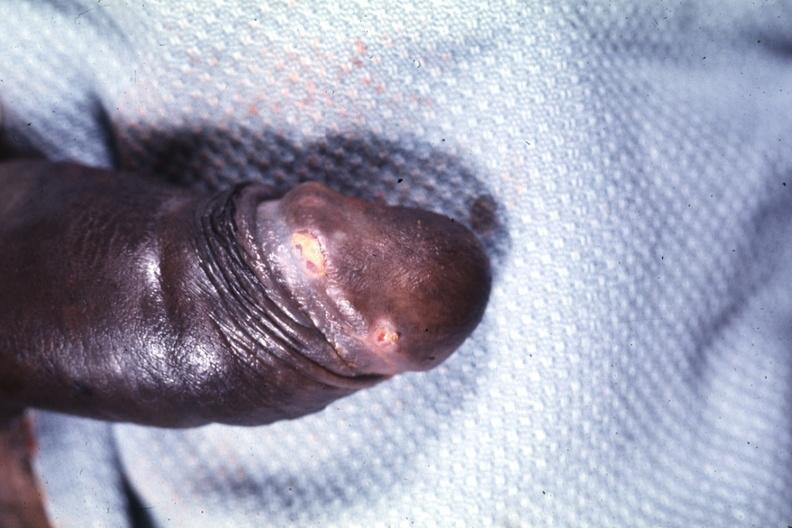does this image show glans ulcers probable herpes?
Answer the question using a single word or phrase. Yes 